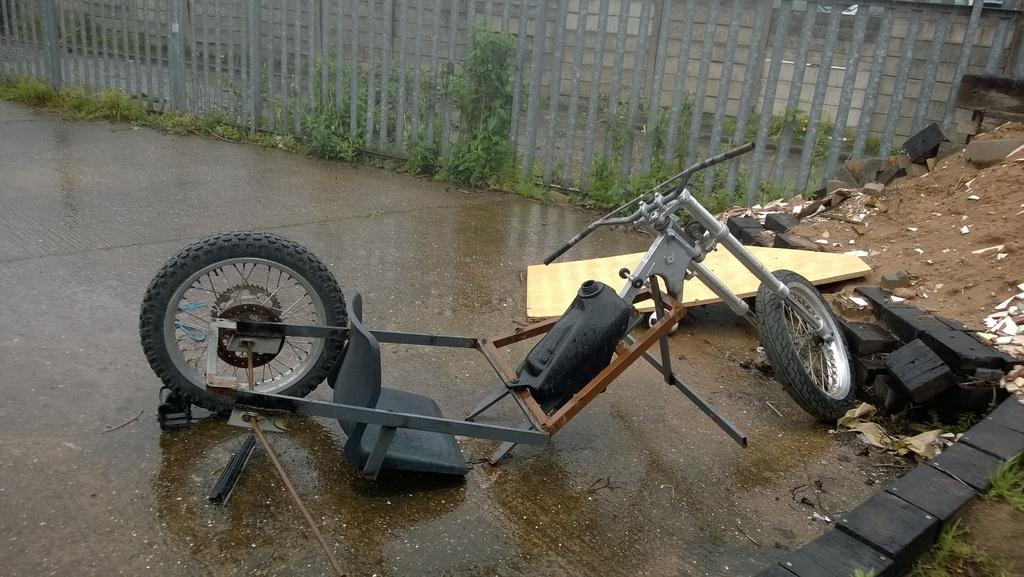What objects in the image have circular shapes? There are two wheels in the image. What is provided for sitting in the image? There is a seat in the image. What can be used to control or steer the object in the image? There is a handle in the image. What feature is present at the back of the image? There is a railing at the back of the image. What type of plants can be seen in the image? There are small plants in green color in the image. What type of silver material is used to make the quilt in the image? There is no quilt or silver material present in the image. How does the expansion of the object in the image affect its functionality? There is no indication of expansion in the image, and therefore its functionality is not affected. 